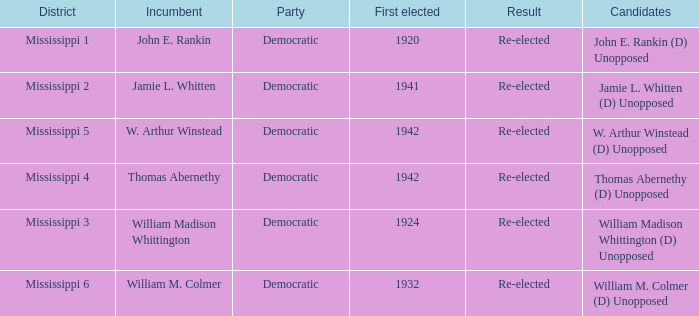What is the incumbent from 1941? Jamie L. Whitten. 